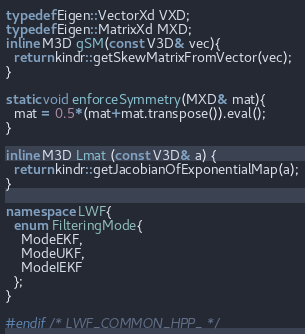Convert code to text. <code><loc_0><loc_0><loc_500><loc_500><_C++_>typedef Eigen::VectorXd VXD;
typedef Eigen::MatrixXd MXD;
inline M3D gSM(const V3D& vec){
  return kindr::getSkewMatrixFromVector(vec);
}

static void enforceSymmetry(MXD& mat){
  mat = 0.5*(mat+mat.transpose()).eval();
}

inline M3D Lmat (const V3D& a) {
  return kindr::getJacobianOfExponentialMap(a);
}

namespace LWF{
  enum FilteringMode{
    ModeEKF,
    ModeUKF,
    ModeIEKF
  };
}

#endif /* LWF_COMMON_HPP_ */
</code> 